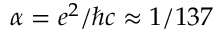Convert formula to latex. <formula><loc_0><loc_0><loc_500><loc_500>\alpha = e ^ { 2 } / \hslash c \approx 1 / 1 3 7</formula> 